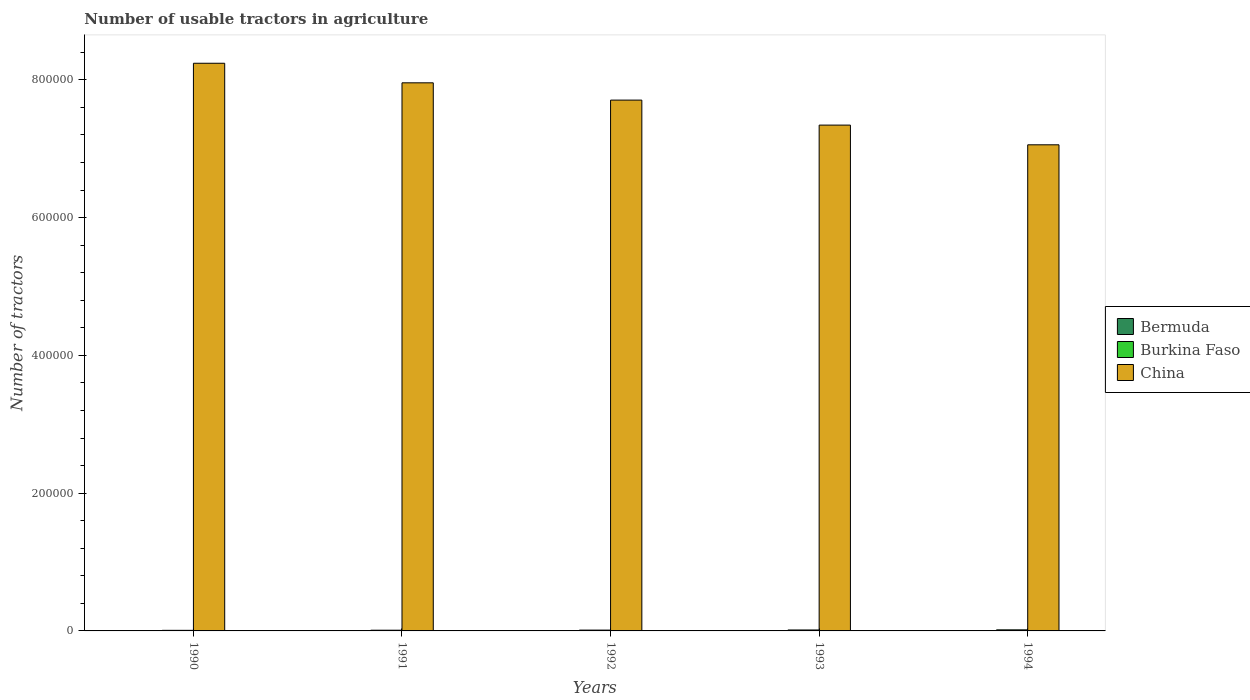How many different coloured bars are there?
Provide a short and direct response. 3. Are the number of bars on each tick of the X-axis equal?
Your answer should be compact. Yes. How many bars are there on the 4th tick from the right?
Keep it short and to the point. 3. What is the label of the 2nd group of bars from the left?
Provide a succinct answer. 1991. In how many cases, is the number of bars for a given year not equal to the number of legend labels?
Ensure brevity in your answer.  0. What is the number of usable tractors in agriculture in China in 1994?
Keep it short and to the point. 7.06e+05. Across all years, what is the maximum number of usable tractors in agriculture in Burkina Faso?
Offer a very short reply. 1560. Across all years, what is the minimum number of usable tractors in agriculture in Bermuda?
Your answer should be very brief. 45. In which year was the number of usable tractors in agriculture in Bermuda maximum?
Your answer should be very brief. 1991. In which year was the number of usable tractors in agriculture in Burkina Faso minimum?
Your answer should be compact. 1990. What is the total number of usable tractors in agriculture in China in the graph?
Ensure brevity in your answer.  3.83e+06. What is the difference between the number of usable tractors in agriculture in Bermuda in 1990 and that in 1991?
Offer a very short reply. -1. What is the difference between the number of usable tractors in agriculture in Burkina Faso in 1992 and the number of usable tractors in agriculture in China in 1991?
Provide a succinct answer. -7.95e+05. What is the average number of usable tractors in agriculture in Burkina Faso per year?
Give a very brief answer. 1200.2. In the year 1993, what is the difference between the number of usable tractors in agriculture in Bermuda and number of usable tractors in agriculture in China?
Your answer should be compact. -7.34e+05. In how many years, is the number of usable tractors in agriculture in China greater than 160000?
Your response must be concise. 5. What is the ratio of the number of usable tractors in agriculture in Bermuda in 1991 to that in 1994?
Offer a very short reply. 1.07. What is the difference between the highest and the second highest number of usable tractors in agriculture in Burkina Faso?
Keep it short and to the point. 180. What is the difference between the highest and the lowest number of usable tractors in agriculture in Burkina Faso?
Provide a succinct answer. 720. Is the sum of the number of usable tractors in agriculture in China in 1991 and 1992 greater than the maximum number of usable tractors in agriculture in Burkina Faso across all years?
Your answer should be very brief. Yes. What does the 1st bar from the left in 1990 represents?
Offer a very short reply. Bermuda. What does the 2nd bar from the right in 1994 represents?
Provide a short and direct response. Burkina Faso. Is it the case that in every year, the sum of the number of usable tractors in agriculture in Burkina Faso and number of usable tractors in agriculture in Bermuda is greater than the number of usable tractors in agriculture in China?
Your answer should be compact. No. Are all the bars in the graph horizontal?
Offer a terse response. No. How many years are there in the graph?
Your answer should be compact. 5. What is the difference between two consecutive major ticks on the Y-axis?
Provide a succinct answer. 2.00e+05. Does the graph contain any zero values?
Your answer should be very brief. No. Where does the legend appear in the graph?
Make the answer very short. Center right. How many legend labels are there?
Make the answer very short. 3. What is the title of the graph?
Offer a very short reply. Number of usable tractors in agriculture. What is the label or title of the X-axis?
Your answer should be very brief. Years. What is the label or title of the Y-axis?
Your response must be concise. Number of tractors. What is the Number of tractors in Burkina Faso in 1990?
Your answer should be compact. 840. What is the Number of tractors in China in 1990?
Offer a terse response. 8.24e+05. What is the Number of tractors of Burkina Faso in 1991?
Keep it short and to the point. 1021. What is the Number of tractors in China in 1991?
Your response must be concise. 7.96e+05. What is the Number of tractors in Burkina Faso in 1992?
Your response must be concise. 1200. What is the Number of tractors in China in 1992?
Your answer should be very brief. 7.71e+05. What is the Number of tractors in Burkina Faso in 1993?
Ensure brevity in your answer.  1380. What is the Number of tractors of China in 1993?
Provide a succinct answer. 7.34e+05. What is the Number of tractors in Bermuda in 1994?
Offer a terse response. 45. What is the Number of tractors of Burkina Faso in 1994?
Your answer should be very brief. 1560. What is the Number of tractors in China in 1994?
Provide a short and direct response. 7.06e+05. Across all years, what is the maximum Number of tractors in Burkina Faso?
Offer a terse response. 1560. Across all years, what is the maximum Number of tractors of China?
Ensure brevity in your answer.  8.24e+05. Across all years, what is the minimum Number of tractors of Burkina Faso?
Make the answer very short. 840. Across all years, what is the minimum Number of tractors of China?
Offer a very short reply. 7.06e+05. What is the total Number of tractors of Bermuda in the graph?
Make the answer very short. 236. What is the total Number of tractors in Burkina Faso in the graph?
Offer a terse response. 6001. What is the total Number of tractors in China in the graph?
Provide a short and direct response. 3.83e+06. What is the difference between the Number of tractors of Burkina Faso in 1990 and that in 1991?
Your response must be concise. -181. What is the difference between the Number of tractors in China in 1990 and that in 1991?
Offer a terse response. 2.84e+04. What is the difference between the Number of tractors of Burkina Faso in 1990 and that in 1992?
Make the answer very short. -360. What is the difference between the Number of tractors of China in 1990 and that in 1992?
Offer a very short reply. 5.35e+04. What is the difference between the Number of tractors in Burkina Faso in 1990 and that in 1993?
Make the answer very short. -540. What is the difference between the Number of tractors in China in 1990 and that in 1993?
Keep it short and to the point. 8.98e+04. What is the difference between the Number of tractors in Bermuda in 1990 and that in 1994?
Keep it short and to the point. 2. What is the difference between the Number of tractors in Burkina Faso in 1990 and that in 1994?
Keep it short and to the point. -720. What is the difference between the Number of tractors of China in 1990 and that in 1994?
Give a very brief answer. 1.18e+05. What is the difference between the Number of tractors of Burkina Faso in 1991 and that in 1992?
Ensure brevity in your answer.  -179. What is the difference between the Number of tractors of China in 1991 and that in 1992?
Make the answer very short. 2.51e+04. What is the difference between the Number of tractors in Bermuda in 1991 and that in 1993?
Provide a short and direct response. 0. What is the difference between the Number of tractors in Burkina Faso in 1991 and that in 1993?
Ensure brevity in your answer.  -359. What is the difference between the Number of tractors in China in 1991 and that in 1993?
Keep it short and to the point. 6.14e+04. What is the difference between the Number of tractors in Burkina Faso in 1991 and that in 1994?
Your answer should be very brief. -539. What is the difference between the Number of tractors in China in 1991 and that in 1994?
Ensure brevity in your answer.  9.00e+04. What is the difference between the Number of tractors of Burkina Faso in 1992 and that in 1993?
Keep it short and to the point. -180. What is the difference between the Number of tractors in China in 1992 and that in 1993?
Your answer should be compact. 3.63e+04. What is the difference between the Number of tractors of Burkina Faso in 1992 and that in 1994?
Your answer should be very brief. -360. What is the difference between the Number of tractors in China in 1992 and that in 1994?
Provide a short and direct response. 6.49e+04. What is the difference between the Number of tractors in Bermuda in 1993 and that in 1994?
Your answer should be compact. 3. What is the difference between the Number of tractors of Burkina Faso in 1993 and that in 1994?
Offer a very short reply. -180. What is the difference between the Number of tractors in China in 1993 and that in 1994?
Keep it short and to the point. 2.86e+04. What is the difference between the Number of tractors in Bermuda in 1990 and the Number of tractors in Burkina Faso in 1991?
Give a very brief answer. -974. What is the difference between the Number of tractors in Bermuda in 1990 and the Number of tractors in China in 1991?
Your response must be concise. -7.96e+05. What is the difference between the Number of tractors of Burkina Faso in 1990 and the Number of tractors of China in 1991?
Your answer should be compact. -7.95e+05. What is the difference between the Number of tractors in Bermuda in 1990 and the Number of tractors in Burkina Faso in 1992?
Give a very brief answer. -1153. What is the difference between the Number of tractors in Bermuda in 1990 and the Number of tractors in China in 1992?
Your answer should be very brief. -7.71e+05. What is the difference between the Number of tractors in Burkina Faso in 1990 and the Number of tractors in China in 1992?
Your answer should be very brief. -7.70e+05. What is the difference between the Number of tractors of Bermuda in 1990 and the Number of tractors of Burkina Faso in 1993?
Give a very brief answer. -1333. What is the difference between the Number of tractors in Bermuda in 1990 and the Number of tractors in China in 1993?
Ensure brevity in your answer.  -7.34e+05. What is the difference between the Number of tractors of Burkina Faso in 1990 and the Number of tractors of China in 1993?
Make the answer very short. -7.33e+05. What is the difference between the Number of tractors of Bermuda in 1990 and the Number of tractors of Burkina Faso in 1994?
Keep it short and to the point. -1513. What is the difference between the Number of tractors in Bermuda in 1990 and the Number of tractors in China in 1994?
Your response must be concise. -7.06e+05. What is the difference between the Number of tractors in Burkina Faso in 1990 and the Number of tractors in China in 1994?
Provide a succinct answer. -7.05e+05. What is the difference between the Number of tractors of Bermuda in 1991 and the Number of tractors of Burkina Faso in 1992?
Your response must be concise. -1152. What is the difference between the Number of tractors in Bermuda in 1991 and the Number of tractors in China in 1992?
Provide a short and direct response. -7.71e+05. What is the difference between the Number of tractors of Burkina Faso in 1991 and the Number of tractors of China in 1992?
Ensure brevity in your answer.  -7.70e+05. What is the difference between the Number of tractors in Bermuda in 1991 and the Number of tractors in Burkina Faso in 1993?
Offer a very short reply. -1332. What is the difference between the Number of tractors in Bermuda in 1991 and the Number of tractors in China in 1993?
Provide a succinct answer. -7.34e+05. What is the difference between the Number of tractors of Burkina Faso in 1991 and the Number of tractors of China in 1993?
Your answer should be very brief. -7.33e+05. What is the difference between the Number of tractors in Bermuda in 1991 and the Number of tractors in Burkina Faso in 1994?
Give a very brief answer. -1512. What is the difference between the Number of tractors of Bermuda in 1991 and the Number of tractors of China in 1994?
Your answer should be very brief. -7.06e+05. What is the difference between the Number of tractors in Burkina Faso in 1991 and the Number of tractors in China in 1994?
Ensure brevity in your answer.  -7.05e+05. What is the difference between the Number of tractors in Bermuda in 1992 and the Number of tractors in Burkina Faso in 1993?
Give a very brief answer. -1332. What is the difference between the Number of tractors of Bermuda in 1992 and the Number of tractors of China in 1993?
Ensure brevity in your answer.  -7.34e+05. What is the difference between the Number of tractors of Burkina Faso in 1992 and the Number of tractors of China in 1993?
Keep it short and to the point. -7.33e+05. What is the difference between the Number of tractors of Bermuda in 1992 and the Number of tractors of Burkina Faso in 1994?
Provide a short and direct response. -1512. What is the difference between the Number of tractors in Bermuda in 1992 and the Number of tractors in China in 1994?
Provide a short and direct response. -7.06e+05. What is the difference between the Number of tractors in Burkina Faso in 1992 and the Number of tractors in China in 1994?
Your answer should be compact. -7.05e+05. What is the difference between the Number of tractors in Bermuda in 1993 and the Number of tractors in Burkina Faso in 1994?
Offer a very short reply. -1512. What is the difference between the Number of tractors of Bermuda in 1993 and the Number of tractors of China in 1994?
Your answer should be very brief. -7.06e+05. What is the difference between the Number of tractors in Burkina Faso in 1993 and the Number of tractors in China in 1994?
Your response must be concise. -7.04e+05. What is the average Number of tractors in Bermuda per year?
Make the answer very short. 47.2. What is the average Number of tractors in Burkina Faso per year?
Make the answer very short. 1200.2. What is the average Number of tractors of China per year?
Offer a very short reply. 7.66e+05. In the year 1990, what is the difference between the Number of tractors in Bermuda and Number of tractors in Burkina Faso?
Offer a very short reply. -793. In the year 1990, what is the difference between the Number of tractors of Bermuda and Number of tractors of China?
Your response must be concise. -8.24e+05. In the year 1990, what is the difference between the Number of tractors in Burkina Faso and Number of tractors in China?
Keep it short and to the point. -8.23e+05. In the year 1991, what is the difference between the Number of tractors in Bermuda and Number of tractors in Burkina Faso?
Your answer should be compact. -973. In the year 1991, what is the difference between the Number of tractors of Bermuda and Number of tractors of China?
Offer a terse response. -7.96e+05. In the year 1991, what is the difference between the Number of tractors in Burkina Faso and Number of tractors in China?
Give a very brief answer. -7.95e+05. In the year 1992, what is the difference between the Number of tractors in Bermuda and Number of tractors in Burkina Faso?
Offer a very short reply. -1152. In the year 1992, what is the difference between the Number of tractors of Bermuda and Number of tractors of China?
Provide a short and direct response. -7.71e+05. In the year 1992, what is the difference between the Number of tractors in Burkina Faso and Number of tractors in China?
Ensure brevity in your answer.  -7.69e+05. In the year 1993, what is the difference between the Number of tractors in Bermuda and Number of tractors in Burkina Faso?
Make the answer very short. -1332. In the year 1993, what is the difference between the Number of tractors of Bermuda and Number of tractors of China?
Offer a terse response. -7.34e+05. In the year 1993, what is the difference between the Number of tractors of Burkina Faso and Number of tractors of China?
Offer a very short reply. -7.33e+05. In the year 1994, what is the difference between the Number of tractors of Bermuda and Number of tractors of Burkina Faso?
Make the answer very short. -1515. In the year 1994, what is the difference between the Number of tractors of Bermuda and Number of tractors of China?
Your answer should be compact. -7.06e+05. In the year 1994, what is the difference between the Number of tractors of Burkina Faso and Number of tractors of China?
Your answer should be very brief. -7.04e+05. What is the ratio of the Number of tractors of Bermuda in 1990 to that in 1991?
Offer a very short reply. 0.98. What is the ratio of the Number of tractors of Burkina Faso in 1990 to that in 1991?
Keep it short and to the point. 0.82. What is the ratio of the Number of tractors of China in 1990 to that in 1991?
Offer a terse response. 1.04. What is the ratio of the Number of tractors in Bermuda in 1990 to that in 1992?
Ensure brevity in your answer.  0.98. What is the ratio of the Number of tractors in Burkina Faso in 1990 to that in 1992?
Your answer should be very brief. 0.7. What is the ratio of the Number of tractors of China in 1990 to that in 1992?
Provide a succinct answer. 1.07. What is the ratio of the Number of tractors of Bermuda in 1990 to that in 1993?
Provide a short and direct response. 0.98. What is the ratio of the Number of tractors in Burkina Faso in 1990 to that in 1993?
Offer a terse response. 0.61. What is the ratio of the Number of tractors of China in 1990 to that in 1993?
Provide a succinct answer. 1.12. What is the ratio of the Number of tractors in Bermuda in 1990 to that in 1994?
Provide a succinct answer. 1.04. What is the ratio of the Number of tractors in Burkina Faso in 1990 to that in 1994?
Give a very brief answer. 0.54. What is the ratio of the Number of tractors in China in 1990 to that in 1994?
Make the answer very short. 1.17. What is the ratio of the Number of tractors of Burkina Faso in 1991 to that in 1992?
Your answer should be compact. 0.85. What is the ratio of the Number of tractors of China in 1991 to that in 1992?
Your answer should be very brief. 1.03. What is the ratio of the Number of tractors in Burkina Faso in 1991 to that in 1993?
Offer a terse response. 0.74. What is the ratio of the Number of tractors in China in 1991 to that in 1993?
Offer a very short reply. 1.08. What is the ratio of the Number of tractors in Bermuda in 1991 to that in 1994?
Offer a terse response. 1.07. What is the ratio of the Number of tractors in Burkina Faso in 1991 to that in 1994?
Provide a succinct answer. 0.65. What is the ratio of the Number of tractors in China in 1991 to that in 1994?
Offer a very short reply. 1.13. What is the ratio of the Number of tractors in Burkina Faso in 1992 to that in 1993?
Give a very brief answer. 0.87. What is the ratio of the Number of tractors in China in 1992 to that in 1993?
Make the answer very short. 1.05. What is the ratio of the Number of tractors in Bermuda in 1992 to that in 1994?
Give a very brief answer. 1.07. What is the ratio of the Number of tractors in Burkina Faso in 1992 to that in 1994?
Ensure brevity in your answer.  0.77. What is the ratio of the Number of tractors of China in 1992 to that in 1994?
Your response must be concise. 1.09. What is the ratio of the Number of tractors in Bermuda in 1993 to that in 1994?
Your answer should be very brief. 1.07. What is the ratio of the Number of tractors in Burkina Faso in 1993 to that in 1994?
Your answer should be compact. 0.88. What is the ratio of the Number of tractors of China in 1993 to that in 1994?
Offer a terse response. 1.04. What is the difference between the highest and the second highest Number of tractors of Burkina Faso?
Make the answer very short. 180. What is the difference between the highest and the second highest Number of tractors in China?
Offer a very short reply. 2.84e+04. What is the difference between the highest and the lowest Number of tractors in Bermuda?
Ensure brevity in your answer.  3. What is the difference between the highest and the lowest Number of tractors in Burkina Faso?
Keep it short and to the point. 720. What is the difference between the highest and the lowest Number of tractors in China?
Give a very brief answer. 1.18e+05. 